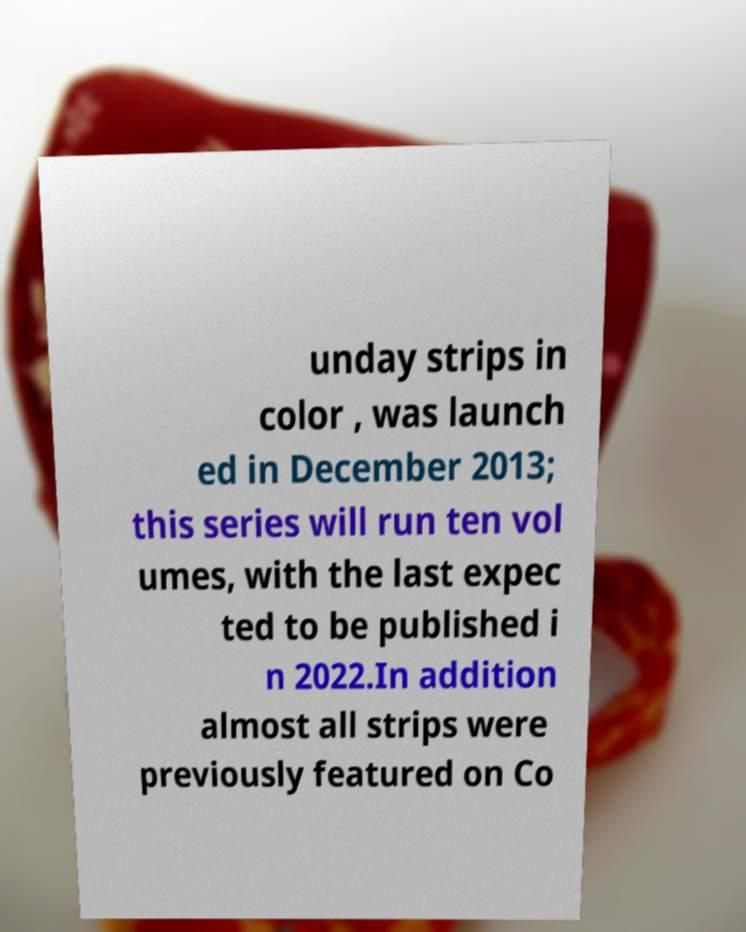I need the written content from this picture converted into text. Can you do that? unday strips in color , was launch ed in December 2013; this series will run ten vol umes, with the last expec ted to be published i n 2022.In addition almost all strips were previously featured on Co 